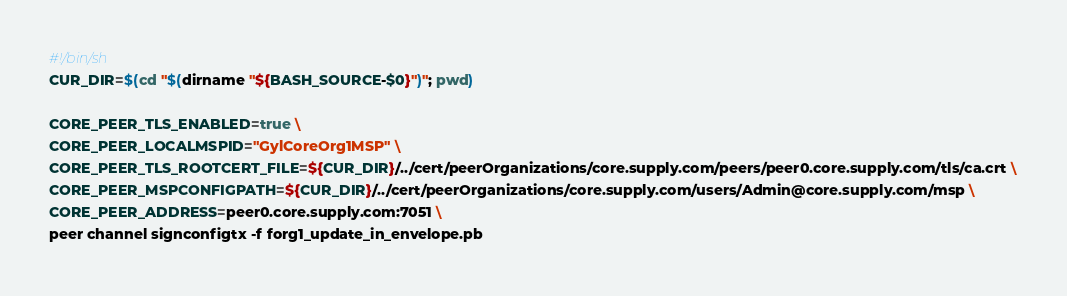<code> <loc_0><loc_0><loc_500><loc_500><_Bash_>#!/bin/sh
CUR_DIR=$(cd "$(dirname "${BASH_SOURCE-$0}")"; pwd)

CORE_PEER_TLS_ENABLED=true \
CORE_PEER_LOCALMSPID="GylCoreOrg1MSP" \
CORE_PEER_TLS_ROOTCERT_FILE=${CUR_DIR}/../cert/peerOrganizations/core.supply.com/peers/peer0.core.supply.com/tls/ca.crt \
CORE_PEER_MSPCONFIGPATH=${CUR_DIR}/../cert/peerOrganizations/core.supply.com/users/Admin@core.supply.com/msp \
CORE_PEER_ADDRESS=peer0.core.supply.com:7051 \
peer channel signconfigtx -f forg1_update_in_envelope.pb</code> 